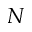Convert formula to latex. <formula><loc_0><loc_0><loc_500><loc_500>N</formula> 